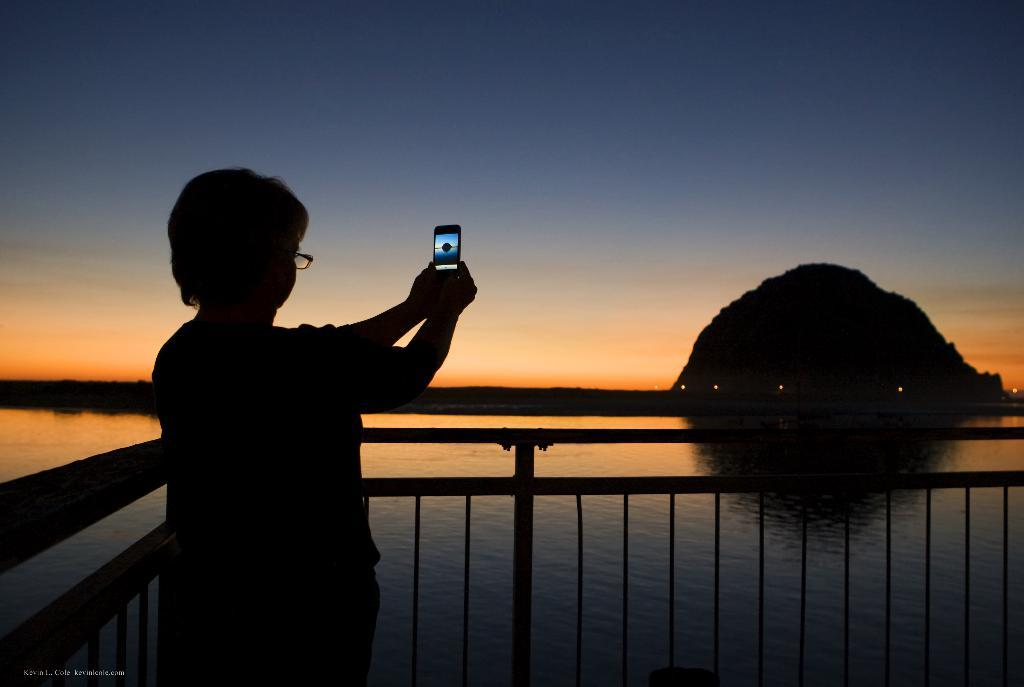Who or what is on the left side of the image? There is a person on the left side of the image. What can be seen on the right side of the image? There is a hill on the right side of the image. What is in the center of the image? There is a fencing in the center of the image. What is visible in the background of the image? There is a sky and water visible in the background of the image. How does the person measure the growth of the bridge in the image? There is no bridge present in the image, so the person cannot measure its growth. 